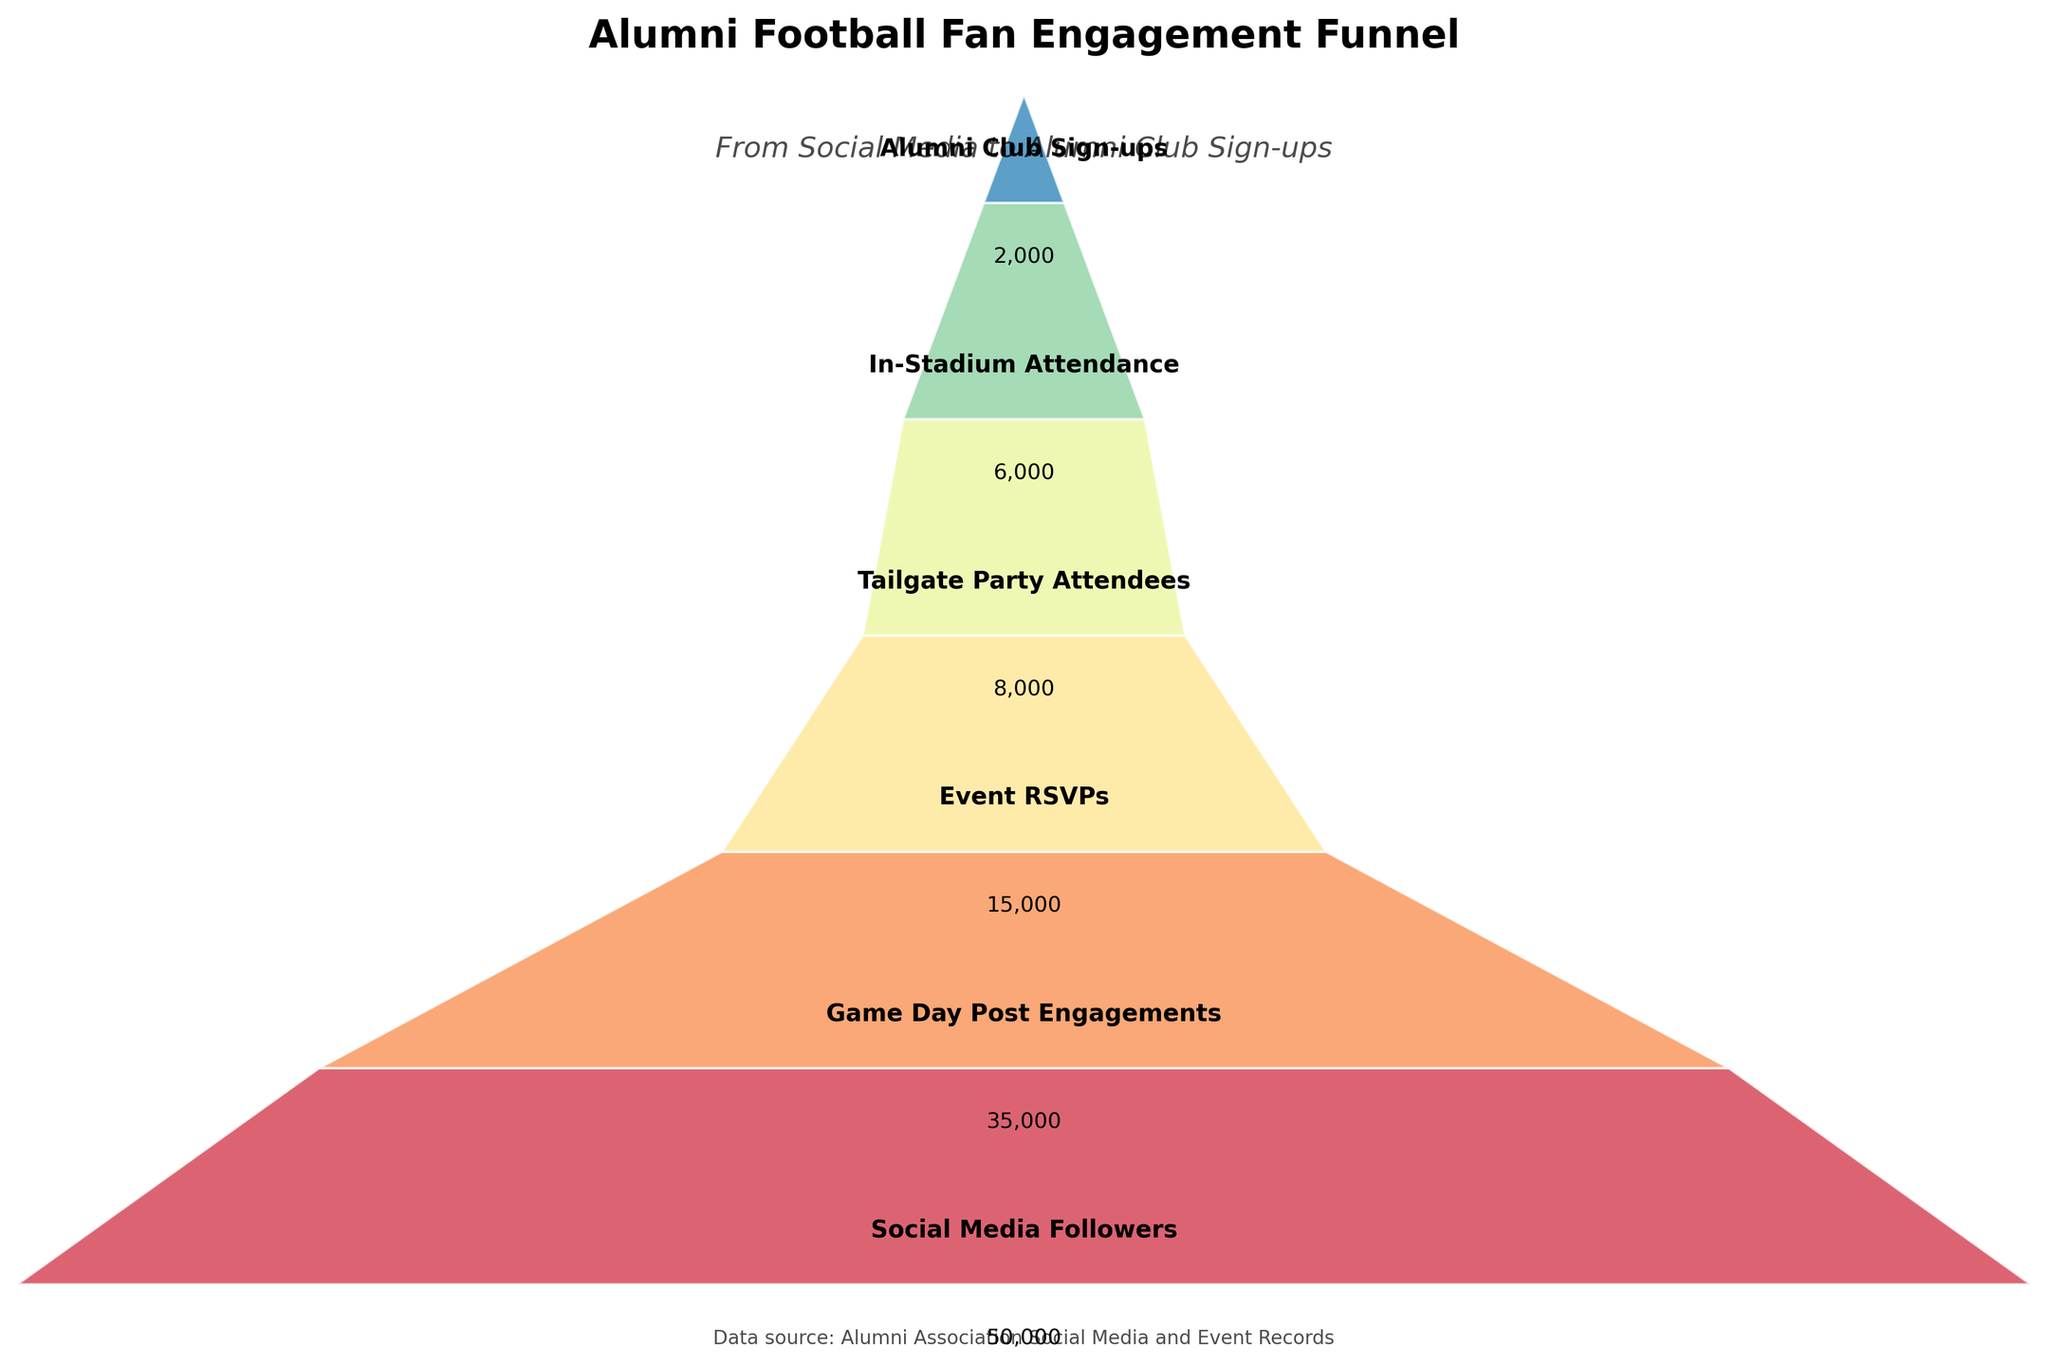What is the title of the funnel chart? The title is displayed at the top of the chart. It reads 'Alumni Football Fan Engagement Funnel'.
Answer: Alumni Football Fan Engagement Funnel What is the number of stages in the funnel? The number of stages can be determined by counting the labeled sections in the funnel. There are six stages in total.
Answer: 6 Which stage has the highest number of participants? The stage with the highest number is the first one. It has the maximum width in the funnel section, labeled as 'Social Media Followers'.
Answer: Social Media Followers What is the total number of participants from 'Social Media Followers' to 'Alumni Club Sign-ups'? Summing the participants across all stages: 50000 (Social Media Followers) + 35000 (Game Day Post Engagements) + 15000 (Event RSVPs) + 8000 (Tailgate Party Attendees) + 6000 (In-Stadium Attendance) + 2000 (Alumni Club Sign-ups) = 116000.
Answer: 116000 How many participants made it to 'In-Stadium Attendance'? The 'In-Stadium Attendance' stage is listed towards the end of the funnel and has an associated figure of 6000 participants.
Answer: 6000 By how much does the number of participants decrease from 'Event RSVPs' to 'Tailgate Party Attendees'? Subtraction of 'Tailgate Party Attendees' from 'Event RSVPs' values: 15000 - 8000 = 7000.
Answer: 7000 What percentage of 'Game Day Post Engagements' resulted in 'Event RSVPs'? Calculate the percentage by dividing 'Event RSVPs' by 'Game Day Post Engagements' and multiplying by 100: (15000 / 35000) * 100 ≈ 42.86%.
Answer: Approximately 42.86% Which stage represents the final goal of the funnel, and how many participants reach it? The last stage in the funnel is 'Alumni Club Sign-ups', with 2000 participants.
Answer: Alumni Club Sign-ups, 2000 What is the difference between 'Tailgate Party Attendees' and 'In-Stadium Attendance'? The difference is found by subtracting 'In-Stadium Attendance' from 'Tailgate Party Attendees': 8000 - 6000 = 2000.
Answer: 2000 What is the conversion rate from 'Social Media Followers' to 'Game Day Post Engagements'? Calculate the conversion rate by dividing 'Game Day Post Engagements' by 'Social Media Followers' and multiplying by 100: (35000 / 50000) * 100 = 70%.
Answer: 70% 